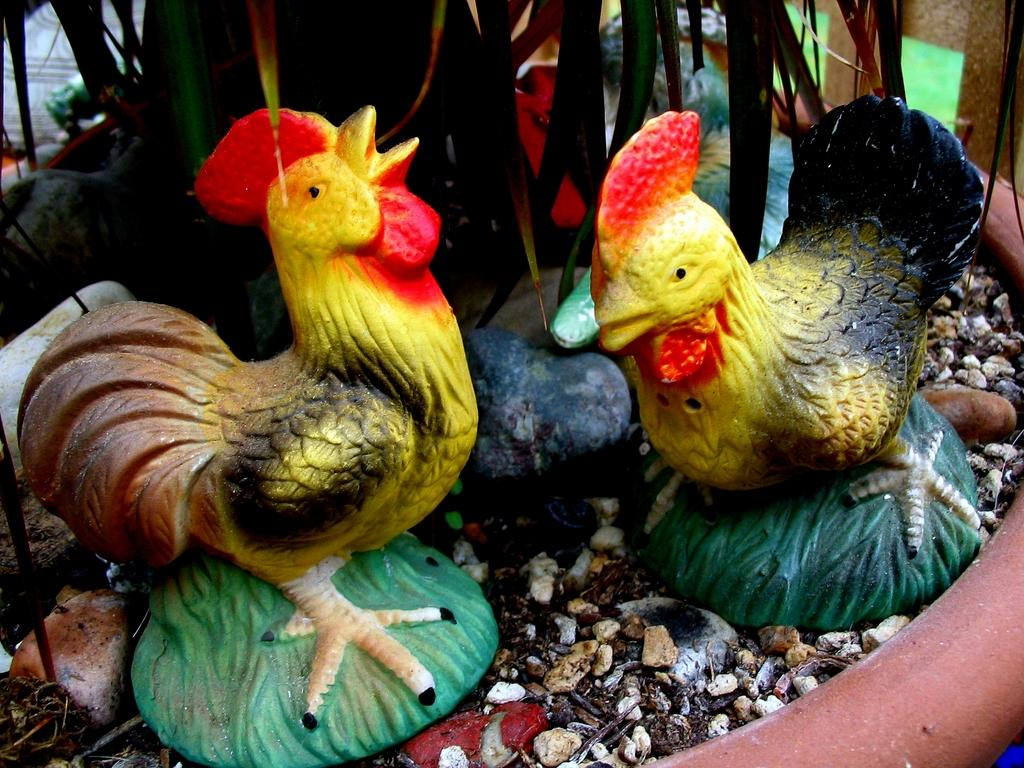Where was the image most likely taken? The image was likely taken indoors. What can be seen in the foreground of the image? There are gravels and sculptures of two birds in the foreground of the image. What type of vegetation is visible in the background of the image? There are leaves visible in the background of the image. What else can be seen in the background of the image? There are other unspecified objects in the background of the image. What type of headwear is the bird wearing in the image? There are no birds wearing headwear in the image, as the birds are sculptures. How does the digestion process of the trees in the image work? There are no trees present in the image, so it is not possible to discuss their digestion process. 